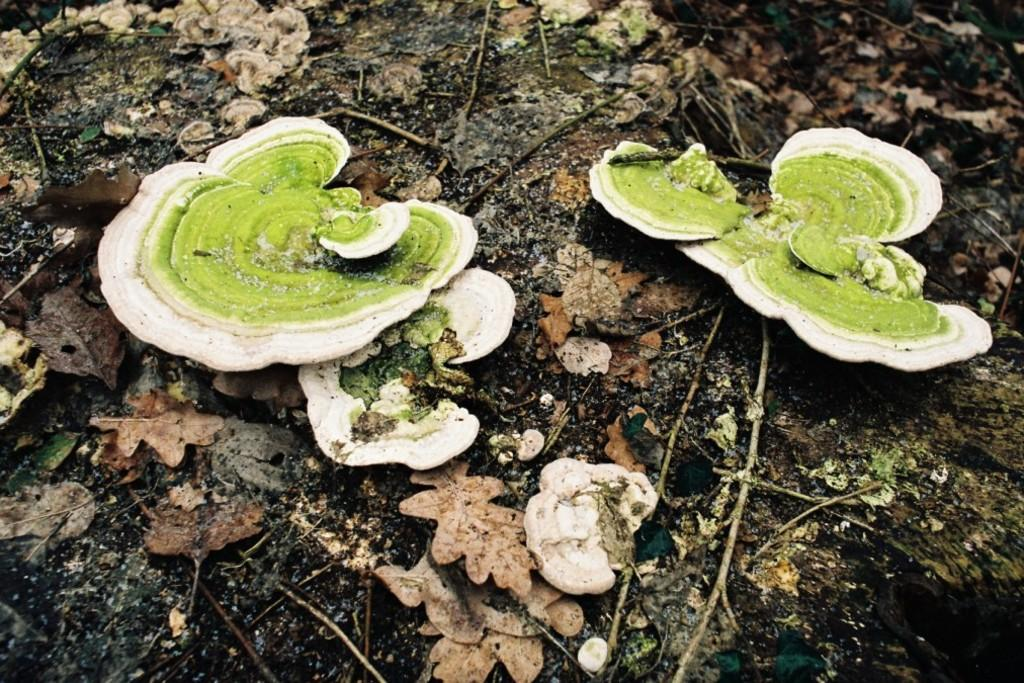What is covering the ground in the image? There are dry leaves on the ground in the image. What else can be seen at the bottom of the image? There are sticks visible at the bottom of the image. What color is the goldfish swimming in the image? There is no goldfish present in the image. What type of crayon is being used to draw on the dry leaves? There is no crayon or drawing activity depicted in the image. 